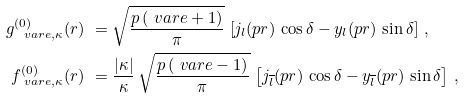<formula> <loc_0><loc_0><loc_500><loc_500>g _ { \ v a r e , \kappa } ^ { ( 0 ) } ( r ) & \ = \sqrt { \frac { p \, ( \ v a r e + 1 ) } { \pi } } \, \left [ j _ { l } ( p r ) \, \cos \delta - y _ { l } ( p r ) \, \sin \delta \right ] \, , \\ f _ { \ v a r e , \kappa } ^ { ( 0 ) } ( r ) & \ = \frac { | \kappa | } { \kappa } \, \sqrt { \frac { p \, ( \ v a r e - 1 ) } { \pi } } \, \left [ j _ { \overline { l } } ( p r ) \, \cos \delta - y _ { \overline { l } } ( p r ) \, \sin \delta \right ] \, ,</formula> 